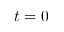Convert formula to latex. <formula><loc_0><loc_0><loc_500><loc_500>t = 0</formula> 